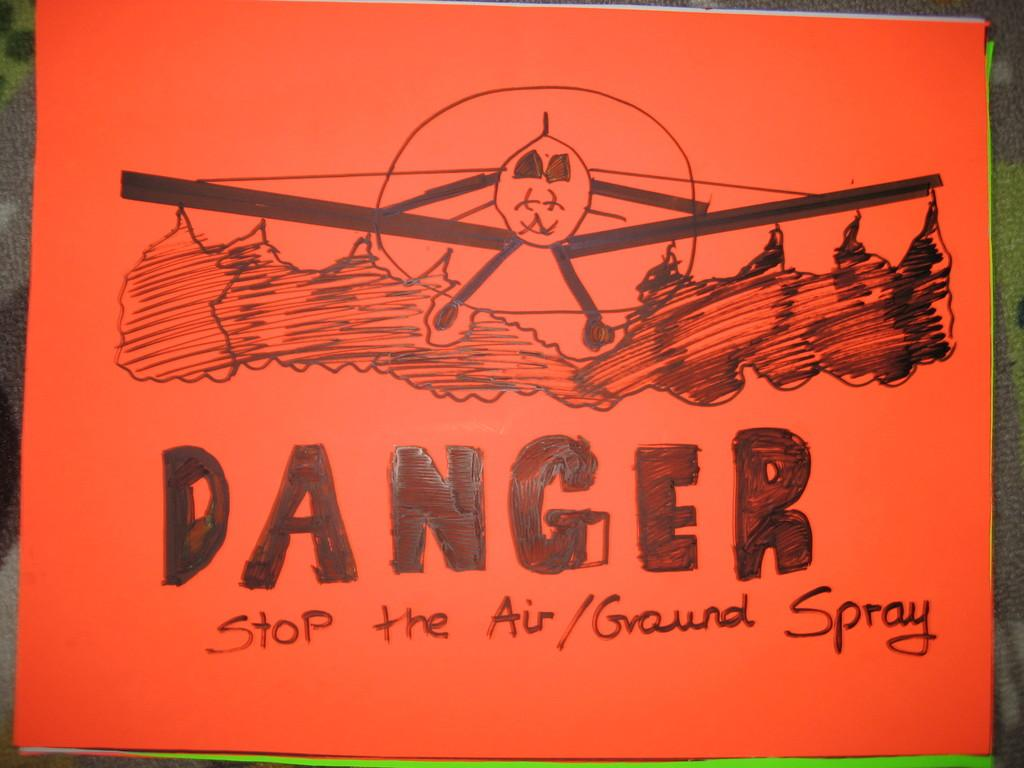<image>
Give a short and clear explanation of the subsequent image. An orange sign with a plane says Danger. 